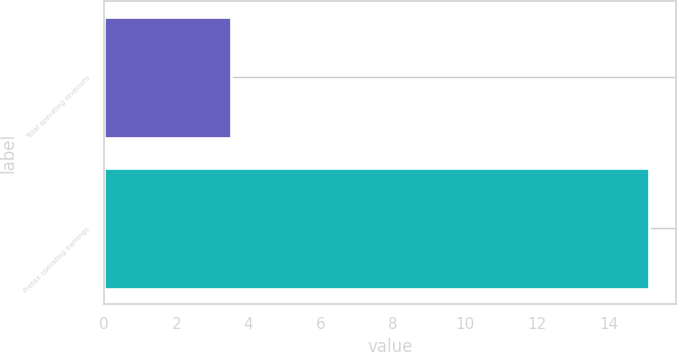Convert chart to OTSL. <chart><loc_0><loc_0><loc_500><loc_500><bar_chart><fcel>Total operating revenues<fcel>Pretax operating earnings<nl><fcel>3.5<fcel>15.1<nl></chart> 